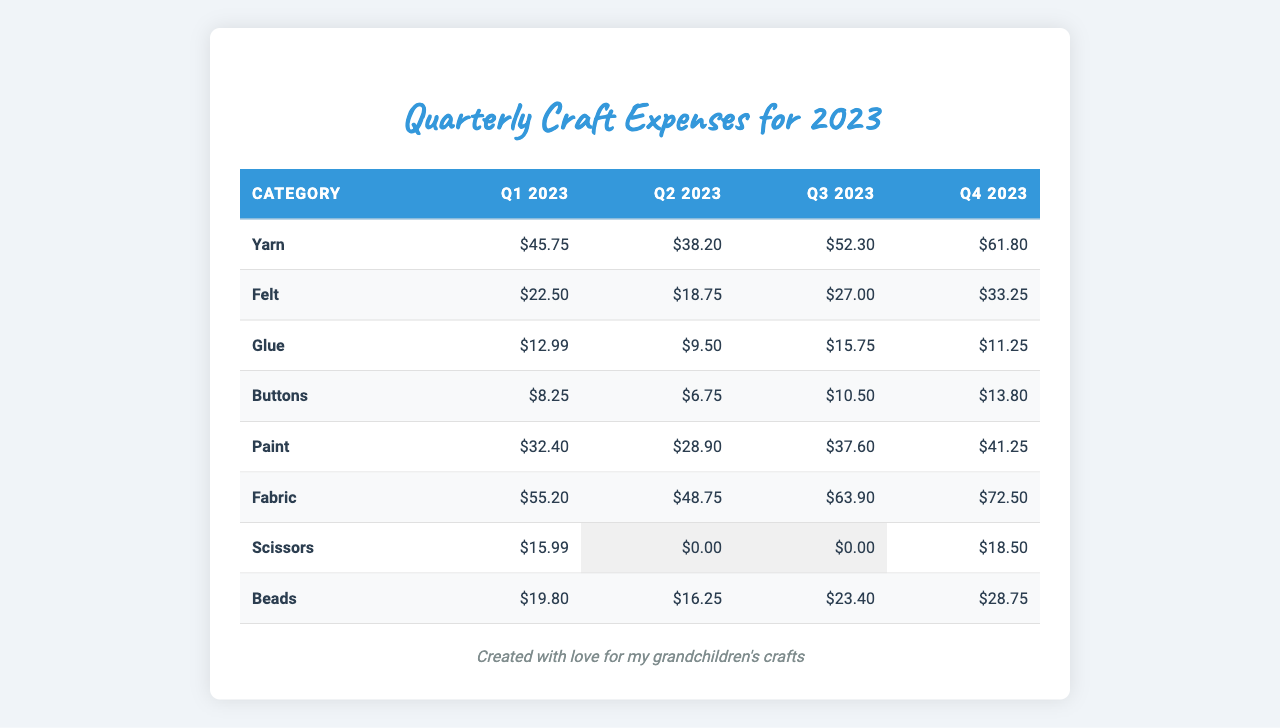What was the total expense for Fabric in Q4 2023? The table shows that the expense for Fabric in Q4 2023 is $72.50.
Answer: $72.50 Which category had the highest expense in Q1 2023? Looking at the values in Q1 2023, Fabric shows the highest expense at $55.20, compared to other categories.
Answer: Fabric What was the total spent on Glue across all quarters? Adding Glue's expenses for each quarter: Q1: $12.99, Q2: $9.50, Q3: $15.75, Q4: $11.25 gives a total of $12.99 + $9.50 + $15.75 + $11.25 = $49.49.
Answer: $49.49 Did the expense for Beads increase from Q2 to Q3? In Q2, the expense for Beads was $16.25, and in Q3 it increased to $23.40. Therefore, the expense did increase.
Answer: Yes What is the average expense for Yarn across all quarters? The total expense for Yarn in all quarters is $45.75 + $38.20 + $52.30 + $61.80 = $198.05. There are 4 quarters, so the average is $198.05 / 4 = $49.51.
Answer: $49.51 Which category saw the largest expense increase from Q1 to Q4? The increase for each category from Q1 to Q4 is calculated: Yarn ($61.80 - $45.75 = $16.05), Felt ($33.25 - $22.50 = $10.75), Glue ($11.25 - $12.99 = -$1.74), Buttons ($13.80 - $8.25 = $5.55), Paint ($41.25 - $32.40 = $8.85), Fabric ($72.50 - $55.20 = $17.30), Scissors ($18.50 - $15.99 = $2.51), Beads ($28.75 - $19.80 = $8.95). The largest increase was for Fabric ($17.30).
Answer: Fabric What was the total expense for craft supplies in Q2 2023? Summing up the expenses for all categories in Q2 2023: Yarn $38.20, Felt $18.75, Glue $9.50, Buttons $6.75, Paint $28.90, Fabric $48.75, Scissors $0, Beads $16.25 gives a total of $38.20 + $18.75 + $9.50 + $6.75 + $28.90 + $48.75 + $0 + $16.25 = $167.15.
Answer: $167.15 Was the expense for Scissors the same for all quarters? Looking at the expenses: Q1: $15.99, Q2: $0, Q3: $0, Q4: $18.50 shows that they are not the same.
Answer: No What was the percentage increase of expense for Paint from Q1 to Q4? The expense for Paint increased from $32.40 in Q1 to $41.25 in Q4. The increase is $41.25 - $32.40 = $8.85. The percentage increase is ($8.85 / $32.40) * 100 = 27.36%.
Answer: 27.36% Which category had the lowest total expense over the four quarters? Calculating the total expenses for each category over all quarters shows Glue: $49.49, Buttons: $39.30, and Scissors: $34.49. Glue has the lowest total.
Answer: Glue 